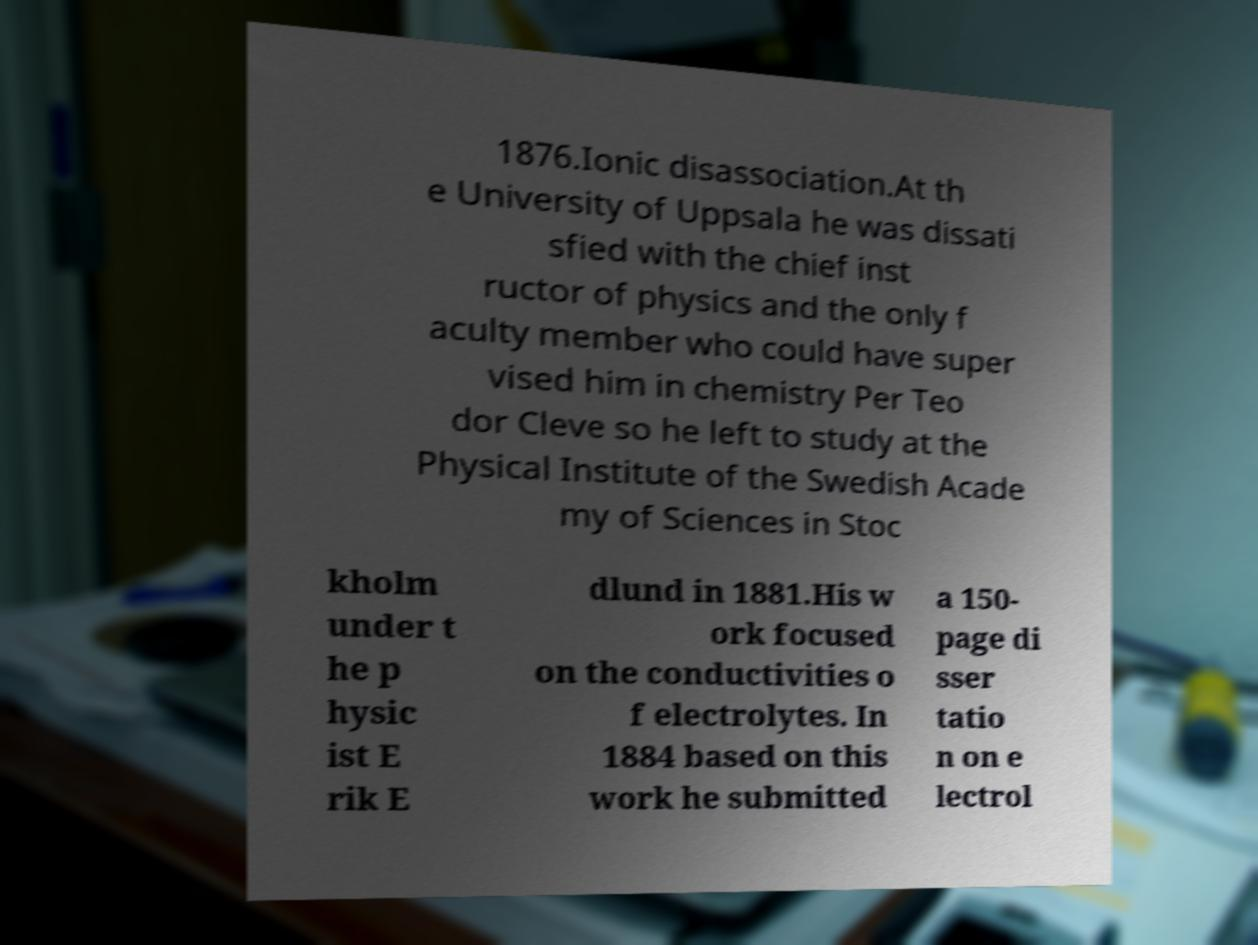Could you extract and type out the text from this image? 1876.Ionic disassociation.At th e University of Uppsala he was dissati sfied with the chief inst ructor of physics and the only f aculty member who could have super vised him in chemistry Per Teo dor Cleve so he left to study at the Physical Institute of the Swedish Acade my of Sciences in Stoc kholm under t he p hysic ist E rik E dlund in 1881.His w ork focused on the conductivities o f electrolytes. In 1884 based on this work he submitted a 150- page di sser tatio n on e lectrol 